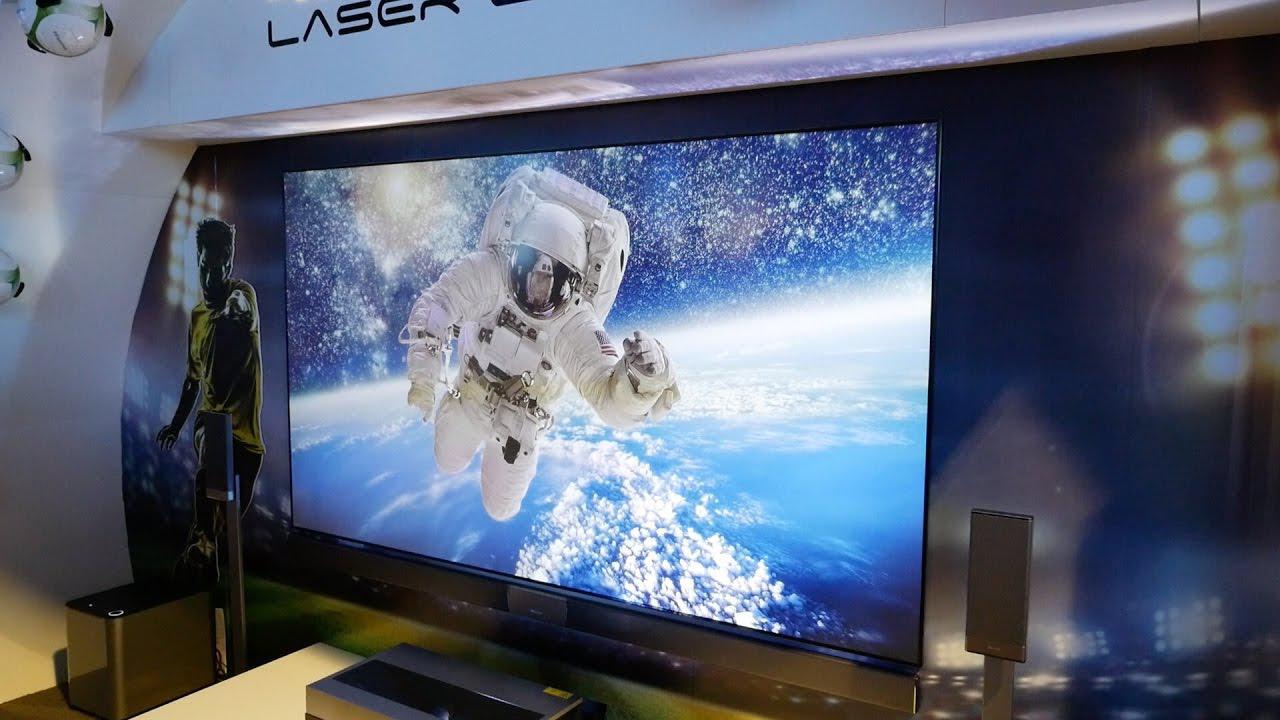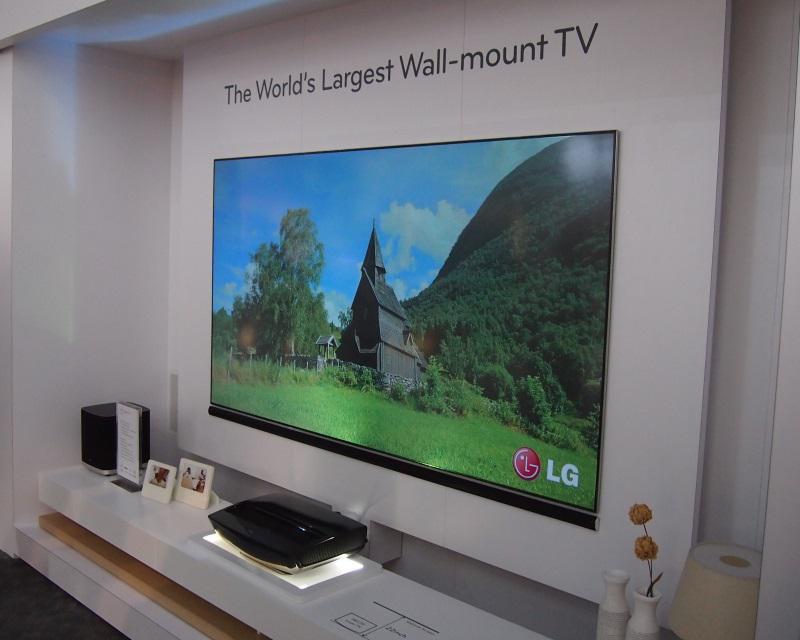The first image is the image on the left, the second image is the image on the right. Given the left and right images, does the statement "One of the television sets is showing a pink flower on a green background." hold true? Answer yes or no. No. The first image is the image on the left, the second image is the image on the right. Considering the images on both sides, is "In at least one image you can see a green background and a hummingbird on the tv that is below gold lettering." valid? Answer yes or no. No. 